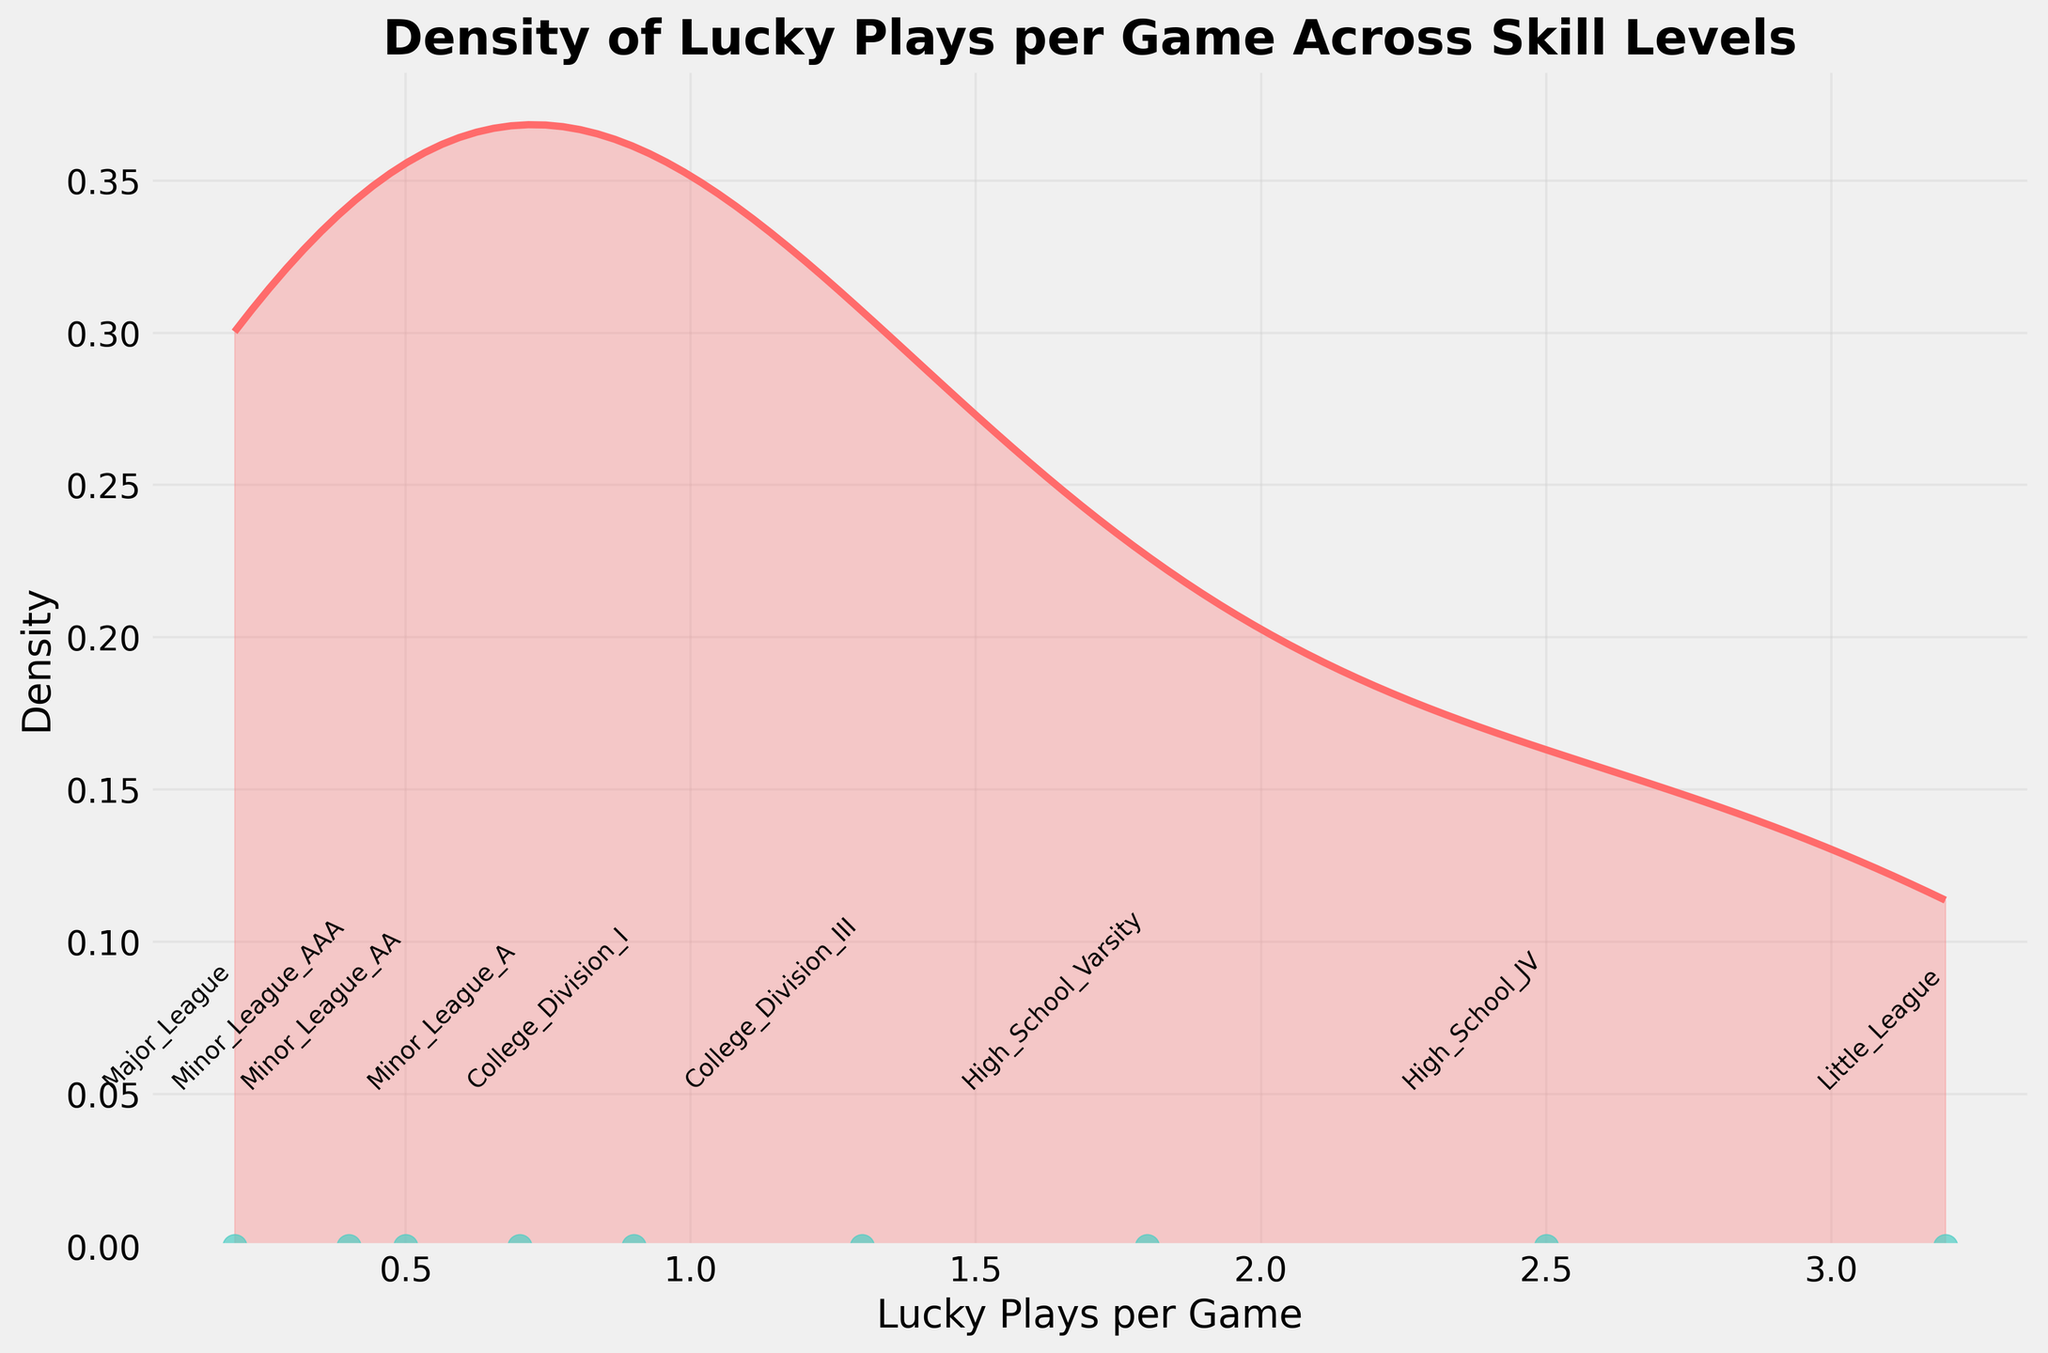what's the title of the figure? The title is usually found at the top of the graph and provides a concise description of what the graph represents. In this case, it is clearly visible at the top of the density plot.
Answer: Density of Lucky Plays per Game Across Skill Levels What is the skill level with the lowest number of lucky plays per game? The data points representing the number of lucky plays per game are annotated with their respective skill levels, and the leftmost point on the x-axis corresponds to "Major League".
Answer: Major League How many lucky plays per game are associated with Little League players? Look at the position of the labeled point for Little League along the x-axis to determine the number of lucky plays per game. It is the rightmost point.
Answer: 3.2 Which skill level has a higher frequency of lucky plays, Minor League AA or College Division I? Comparing the positions of "Minor League AA" and "College Division I" on the x-axis, College Division I is further to the right, indicating a higher number of lucky plays per game.
Answer: College Division I What's the general trend in the number of lucky plays per game as skill levels increase? Observing the position of the points from left to right, as the skill levels progress from Little League to Major League, the number of lucky plays per game decreases.
Answer: Decreases Compare the density peaks for high school JV and Minor League AA players. Which group is more common to have lucky plays per game? To identify the density peaks, compare the height of the density curve above the points representing "High School JV" and "Minor League AA". The density near "High School JV" is significantly higher.
Answer: High School JV At which range on the x-axis does the density peak for lucky plays per game occur? The peak of the density curve indicates the range with the highest frequency. Observing the location of the highest point of the red density curve, it occurs around the value where Little League has its point (~3.2 lucky plays per game).
Answer: Around 3.2 lucky plays per game Given the density plot, which type of comparison would likely be inaccurate: comparing individual skill levels or comparing ranges? Comparing individual skill levels directly is based on single data points, which might be less accurate than comparing ranges where density can provide a better aggregate measure.
Answer: Comparing individual skill levels How does the density of lucky plays per game change between College Division III and College Division I? Observing the density curve between the points for "College Division III" and "College Division I", the density decreases significantly as we move from 1.3 to 0.9 lucky plays per game.
Answer: Decreases How does the visual representation (e.g., color, line) of the density curve help in interpreting the frequency of lucky plays per game? The density curve's color (red) and its filled area give a clear visual indication of the concentration of data points, highlighting where lucky plays per game are more or less frequent. The higher the peak, the higher the frequency.
Answer: It highlights frequency through color and filled areas 